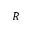<formula> <loc_0><loc_0><loc_500><loc_500>R</formula> 